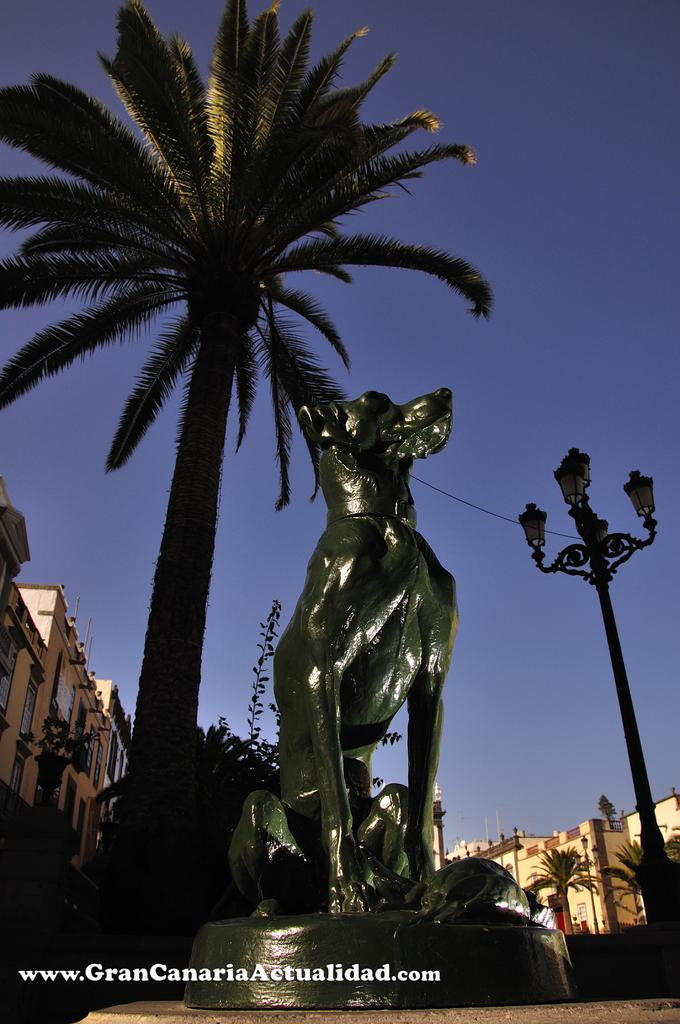What is the main subject in the center of the image? There is a statue in the center of the image. What can be seen in the background of the image? There is a tree, a pole, and buildings in the background of the image. How many pieces of furniture can be seen in the image? There is no furniture present in the image. What type of nut is being cracked by the statue in the image? There is no nut or any activity involving a nut depicted in the image. 